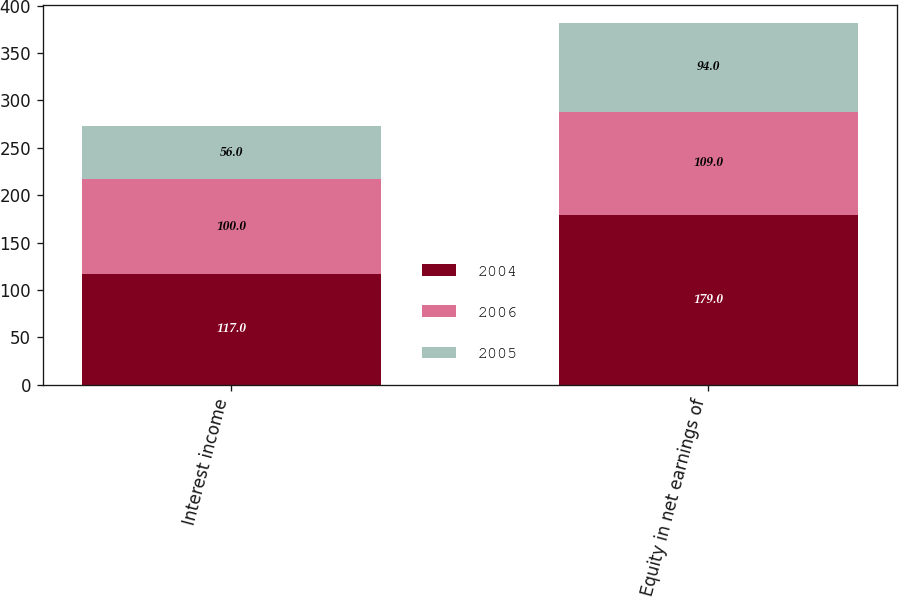<chart> <loc_0><loc_0><loc_500><loc_500><stacked_bar_chart><ecel><fcel>Interest income<fcel>Equity in net earnings of<nl><fcel>2004<fcel>117<fcel>179<nl><fcel>2006<fcel>100<fcel>109<nl><fcel>2005<fcel>56<fcel>94<nl></chart> 